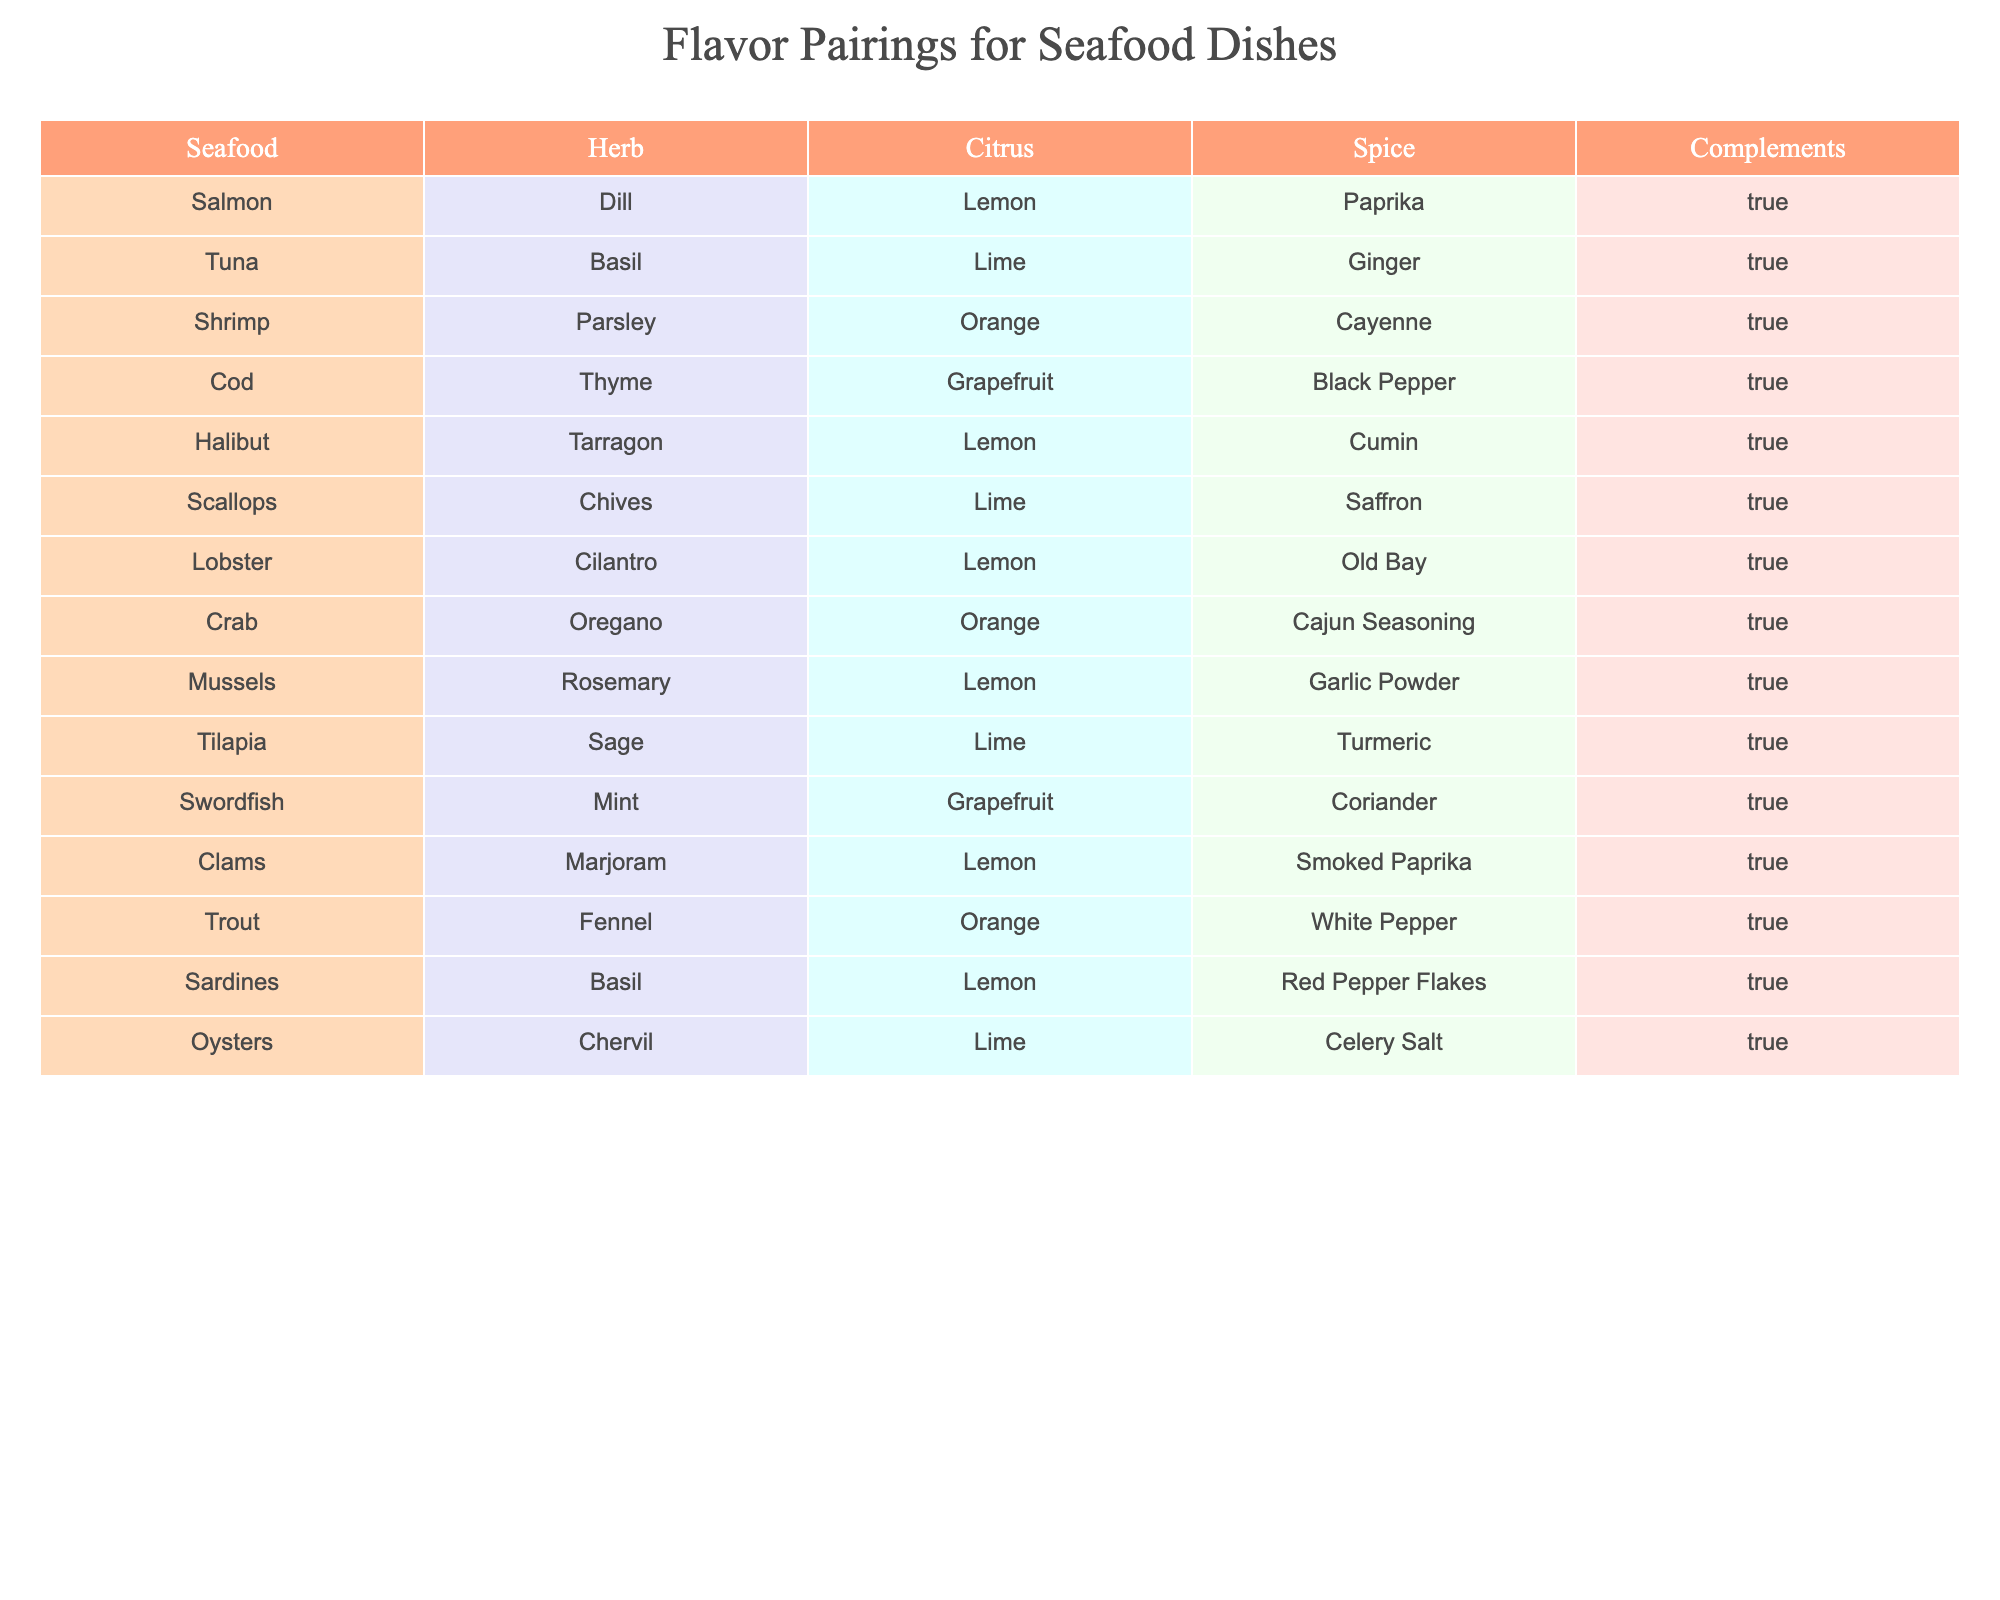What seafood pairs best with lemon? Looking at the table, several seafood options have "Lemon" listed under the Citrus column: Salmon, Halibut, Lobster, Mussels, Clams, Sardines, and Oysters. These are all the seafood that pairs well with lemon.
Answer: Salmon, Halibut, Lobster, Mussels, Clams, Sardines, Oysters Is there any seafood that pairs with grapefruit? From the table, we can see that Swordfish and Cod both have "Grapefruit" in the Citrus column. Thus, these seafood items pair with grapefruit.
Answer: Swordfish, Cod How many different types of herbs are used with shrimp, cod, and mussels? Checking the table reveals that Shrimp is paired with Parsley, Cod with Thyme, and Mussels with Rosemary. This gives us three unique herbs: Parsley, Thyme, and Rosemary.
Answer: 3 Does tuna pairing with ginger complement? Referring to the table, Tuna has "True" in the Complements column when paired with Ginger. Therefore, the pairing does complement.
Answer: Yes What is the total number of different spices used across all seafood in this table? By listing all the unique spices paired with each seafood, we find: Paprika, Ginger, Cayenne, Black Pepper, Cumin, Saffron, Old Bay, Cajun Seasoning, Garlic Powder, Turmeric, Coriander, and Smoked Paprika. Counting these gives a total of 12 unique spices.
Answer: 12 Which seafood has the unique combination of cilantro and lemon? From the table, only Lobster has both "Cilantro" listed under the Herb column and "Lemon" under the Citrus column.
Answer: Lobster Is orange ever paired with shrimp? By examining the table, we see that Shrimp is paired with Orange in the Citrus column, confirming that it is indeed included.
Answer: Yes Which spices are used with seafood that pairs with lime? Looking through the table for seafood that has "Lime" in the Citrus column, we find: Tuna (Ginger), Scallops (Saffron), Tilapia (Turmeric), and Oysters (Celery Salt). This makes the spices Ginger, Saffron, Turmeric, and Celery Salt.
Answer: Ginger, Saffron, Turmeric, Celery Salt 